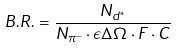Convert formula to latex. <formula><loc_0><loc_0><loc_500><loc_500>B . R . = \frac { N _ { d ^ { * } } } { N _ { \pi ^ { - } } \cdot \epsilon \Delta \Omega \cdot F \cdot C }</formula> 